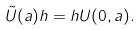Convert formula to latex. <formula><loc_0><loc_0><loc_500><loc_500>\tilde { U } ( a ) h = h U ( 0 , a ) .</formula> 